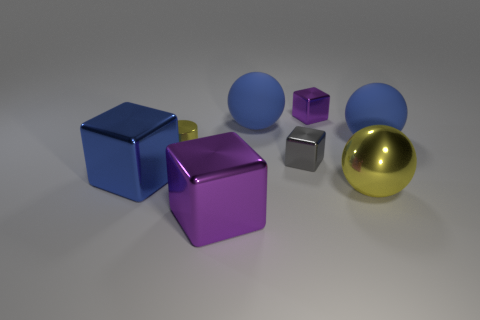There is a metallic ball; is it the same color as the rubber ball on the left side of the large yellow metal ball?
Make the answer very short. No. What is the cylinder made of?
Make the answer very short. Metal. There is a shiny object that is in front of the yellow ball; what color is it?
Provide a short and direct response. Purple. What number of large metal blocks are the same color as the tiny cylinder?
Offer a terse response. 0. What number of large cubes are both left of the tiny yellow shiny cylinder and in front of the yellow sphere?
Give a very brief answer. 0. What shape is the yellow metallic thing that is the same size as the gray cube?
Ensure brevity in your answer.  Cylinder. How big is the cylinder?
Offer a very short reply. Small. What material is the large cube on the right side of the large blue thing that is left of the big rubber thing that is to the left of the small purple thing?
Provide a short and direct response. Metal. What color is the big ball that is the same material as the tiny gray cube?
Your answer should be compact. Yellow. There is a big blue sphere that is on the left side of the blue matte object that is on the right side of the yellow metal sphere; how many tiny purple things are to the left of it?
Make the answer very short. 0. 